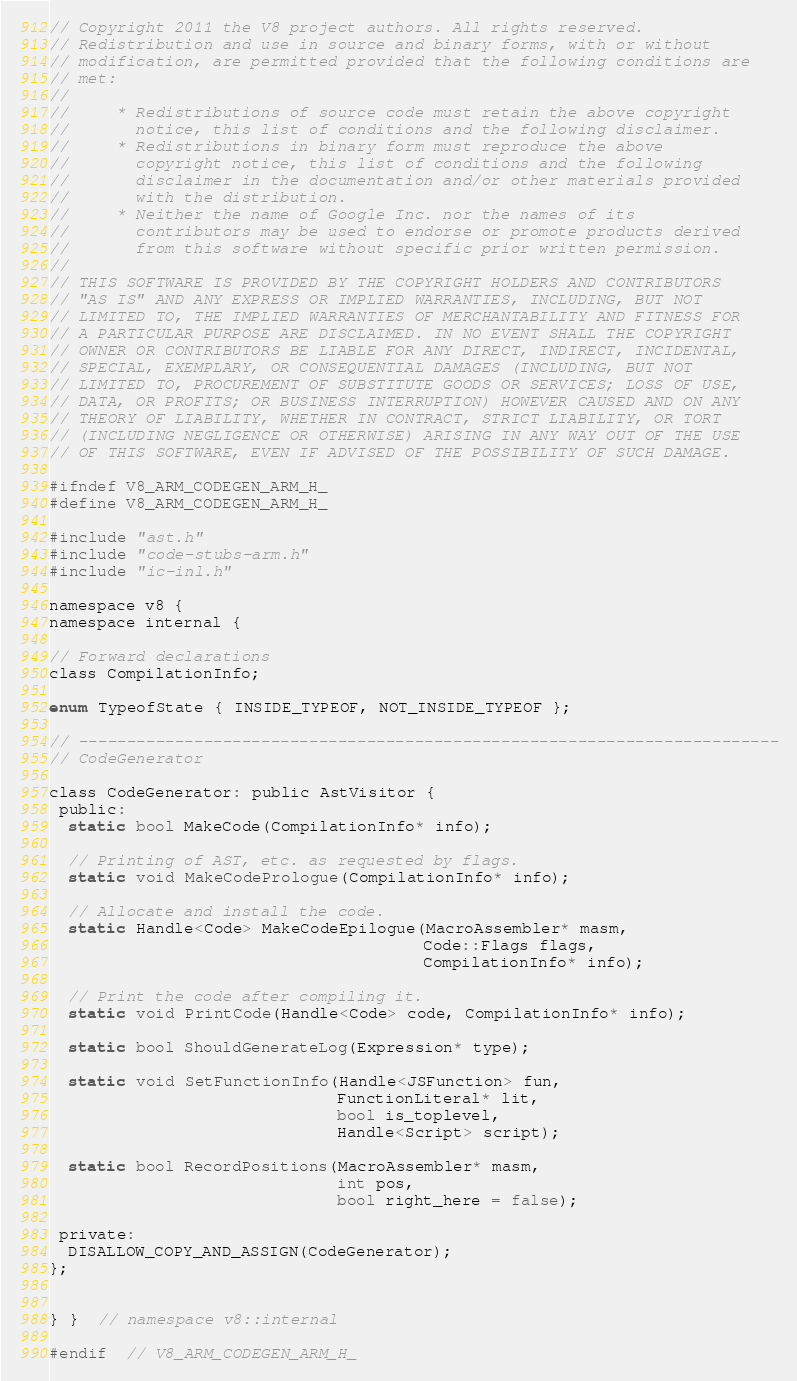<code> <loc_0><loc_0><loc_500><loc_500><_C_>// Copyright 2011 the V8 project authors. All rights reserved.
// Redistribution and use in source and binary forms, with or without
// modification, are permitted provided that the following conditions are
// met:
//
//     * Redistributions of source code must retain the above copyright
//       notice, this list of conditions and the following disclaimer.
//     * Redistributions in binary form must reproduce the above
//       copyright notice, this list of conditions and the following
//       disclaimer in the documentation and/or other materials provided
//       with the distribution.
//     * Neither the name of Google Inc. nor the names of its
//       contributors may be used to endorse or promote products derived
//       from this software without specific prior written permission.
//
// THIS SOFTWARE IS PROVIDED BY THE COPYRIGHT HOLDERS AND CONTRIBUTORS
// "AS IS" AND ANY EXPRESS OR IMPLIED WARRANTIES, INCLUDING, BUT NOT
// LIMITED TO, THE IMPLIED WARRANTIES OF MERCHANTABILITY AND FITNESS FOR
// A PARTICULAR PURPOSE ARE DISCLAIMED. IN NO EVENT SHALL THE COPYRIGHT
// OWNER OR CONTRIBUTORS BE LIABLE FOR ANY DIRECT, INDIRECT, INCIDENTAL,
// SPECIAL, EXEMPLARY, OR CONSEQUENTIAL DAMAGES (INCLUDING, BUT NOT
// LIMITED TO, PROCUREMENT OF SUBSTITUTE GOODS OR SERVICES; LOSS OF USE,
// DATA, OR PROFITS; OR BUSINESS INTERRUPTION) HOWEVER CAUSED AND ON ANY
// THEORY OF LIABILITY, WHETHER IN CONTRACT, STRICT LIABILITY, OR TORT
// (INCLUDING NEGLIGENCE OR OTHERWISE) ARISING IN ANY WAY OUT OF THE USE
// OF THIS SOFTWARE, EVEN IF ADVISED OF THE POSSIBILITY OF SUCH DAMAGE.

#ifndef V8_ARM_CODEGEN_ARM_H_
#define V8_ARM_CODEGEN_ARM_H_

#include "ast.h"
#include "code-stubs-arm.h"
#include "ic-inl.h"

namespace v8 {
namespace internal {

// Forward declarations
class CompilationInfo;

enum TypeofState { INSIDE_TYPEOF, NOT_INSIDE_TYPEOF };

// -------------------------------------------------------------------------
// CodeGenerator

class CodeGenerator: public AstVisitor {
 public:
  static bool MakeCode(CompilationInfo* info);

  // Printing of AST, etc. as requested by flags.
  static void MakeCodePrologue(CompilationInfo* info);

  // Allocate and install the code.
  static Handle<Code> MakeCodeEpilogue(MacroAssembler* masm,
                                       Code::Flags flags,
                                       CompilationInfo* info);

  // Print the code after compiling it.
  static void PrintCode(Handle<Code> code, CompilationInfo* info);

  static bool ShouldGenerateLog(Expression* type);

  static void SetFunctionInfo(Handle<JSFunction> fun,
                              FunctionLiteral* lit,
                              bool is_toplevel,
                              Handle<Script> script);

  static bool RecordPositions(MacroAssembler* masm,
                              int pos,
                              bool right_here = false);

 private:
  DISALLOW_COPY_AND_ASSIGN(CodeGenerator);
};


} }  // namespace v8::internal

#endif  // V8_ARM_CODEGEN_ARM_H_
</code> 